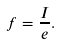<formula> <loc_0><loc_0><loc_500><loc_500>f = \frac { I } { e } .</formula> 